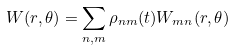<formula> <loc_0><loc_0><loc_500><loc_500>W ( r , \theta ) = \sum _ { n , m } \rho _ { n m } ( t ) W _ { m n } ( r , \theta )</formula> 